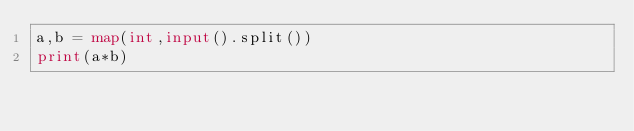Convert code to text. <code><loc_0><loc_0><loc_500><loc_500><_Python_>a,b = map(int,input().split())
print(a*b)</code> 